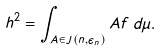<formula> <loc_0><loc_0><loc_500><loc_500>h ^ { 2 } = \int _ { A \in J ( n , \epsilon _ { n } ) } A f \, d \mu .</formula> 